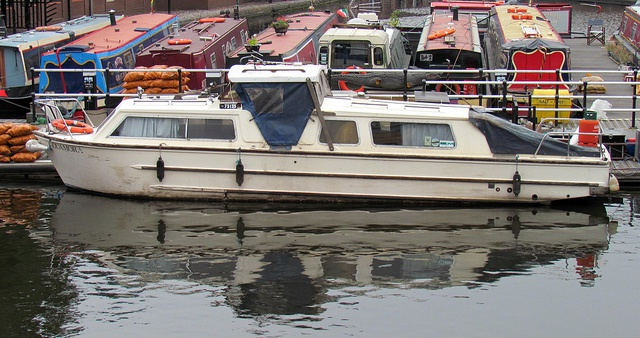Describe the objects in this image and their specific colors. I can see boat in darkgreen, darkgray, lightgray, black, and gray tones, boat in darkgreen, black, salmon, gray, and navy tones, boat in darkgreen, black, gray, and darkgray tones, boat in darkgreen, maroon, darkgray, brown, and purple tones, and boat in darkgreen, lightpink, brown, black, and gray tones in this image. 